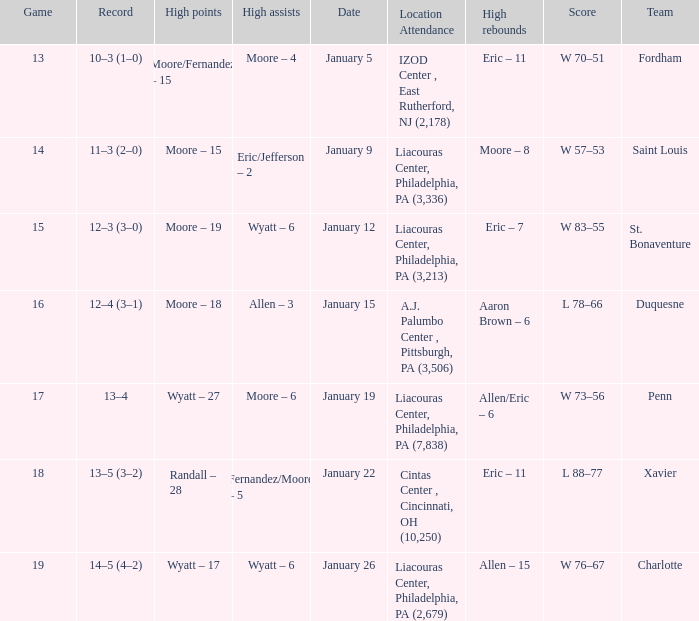What team was Temple playing on January 19? Penn. 